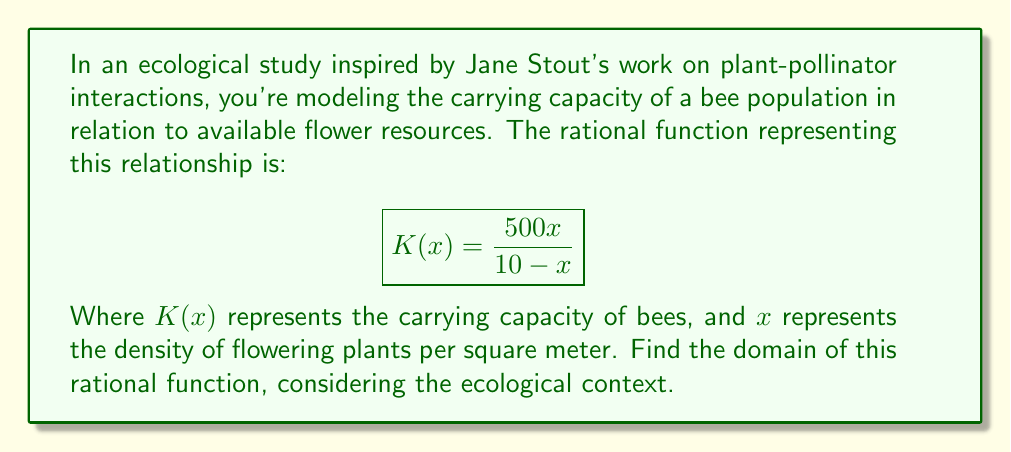Provide a solution to this math problem. To find the domain of this rational function, we need to consider both mathematical and ecological constraints:

1) Mathematically, a rational function is undefined when its denominator equals zero. So, we need to solve:
   $$10 - x = 0$$
   $$x = 10$$

2) The denominator can't be zero, so $x \neq 10$.

3) Ecologically, $x$ represents plant density, which can't be negative. So, $x \geq 0$.

4) The numerator doesn't impose any restrictions on the domain.

5) However, for the carrying capacity to be positive (ecologically meaningful), we need:
   $$\frac{500x}{10 - x} > 0$$

   This is true when both numerator and denominator have the same sign:
   - When $0 \leq x < 10$, both are positive.
   - When $x > 10$, the numerator is positive but the denominator is negative, giving a negative carrying capacity, which is not ecologically meaningful.

6) Combining these constraints, the domain is all $x$ values where $0 \leq x < 10$.
Answer: $[0, 10)$ 